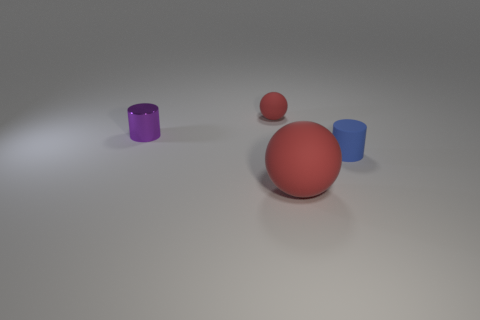The tiny matte object to the right of the big thing has what shape? The small matte object to the right of the larger central sphere appears to be a cylinder. Its surface reflects light differently compared to the shinier spheres, indicating its matte finish. The item's height is greater than its diameter, characteristic of a cylindrical shape. 